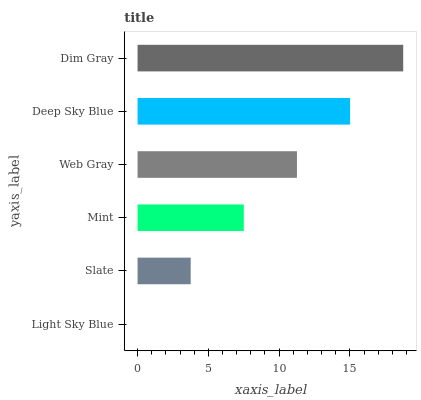Is Light Sky Blue the minimum?
Answer yes or no. Yes. Is Dim Gray the maximum?
Answer yes or no. Yes. Is Slate the minimum?
Answer yes or no. No. Is Slate the maximum?
Answer yes or no. No. Is Slate greater than Light Sky Blue?
Answer yes or no. Yes. Is Light Sky Blue less than Slate?
Answer yes or no. Yes. Is Light Sky Blue greater than Slate?
Answer yes or no. No. Is Slate less than Light Sky Blue?
Answer yes or no. No. Is Web Gray the high median?
Answer yes or no. Yes. Is Mint the low median?
Answer yes or no. Yes. Is Mint the high median?
Answer yes or no. No. Is Dim Gray the low median?
Answer yes or no. No. 